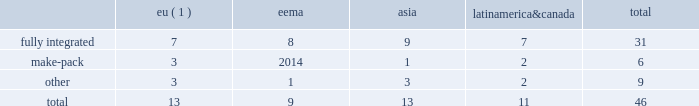2022 the failure of our information systems to function as intended or their penetration by outside parties with the intent to corrupt them or our failure to comply with privacy laws and regulations could result in business disruption , litigation and regulatory action , and loss of revenue , assets or personal or other confidential data .
We use information systems to help manage business processes , collect and interpret business data and communicate internally and externally with employees , suppliers , customers and others .
Some of these information systems are managed by third-party service providers .
We have backup systems and business continuity plans in place , and we take care to protect our systems and data from unauthorized access .
Nevertheless , failure of our systems to function as intended , or penetration of our systems by outside parties intent on extracting or corrupting information or otherwise disrupting business processes , could place us at a competitive disadvantage , result in a loss of revenue , assets or personal or other sensitive data , litigation and regulatory action , cause damage to our reputation and that of our brands and result in significant remediation and other costs .
Failure to protect personal data and respect the rights of data subjects could subject us to substantial fines under regulations such as the eu general data protection regulation .
2022 we may be required to replace third-party contract manufacturers or service providers with our own resources .
In certain instances , we contract with third parties to manufacture some of our products or product parts or to provide other services .
We may be unable to renew these agreements on satisfactory terms for numerous reasons , including government regulations .
Accordingly , our costs may increase significantly if we must replace such third parties with our own resources .
Item 1b .
Unresolved staff comments .
Item 2 .
Properties .
At december 31 , 2017 , we operated and owned 46 manufacturing facilities and maintained contract manufacturing relationships with 25 third-party manufacturers across 23 markets .
In addition , we work with 38 third-party operators in indonesia who manufacture our hand-rolled cigarettes .
Pmi-owned manufacturing facilities eema asia america canada total .
( 1 ) includes facilities that produced heated tobacco units in 2017 .
In 2017 , 23 of our facilities each manufactured over 10 billion cigarettes , of which eight facilities each produced over 30 billion units .
Our largest factories are in karawang and sukorejo ( indonesia ) , izmir ( turkey ) , krakow ( poland ) , st .
Petersburg and krasnodar ( russia ) , batangas and marikina ( philippines ) , berlin ( germany ) , kharkiv ( ukraine ) , and kutna hora ( czech republic ) .
Our smallest factories are mostly in latin america and asia , where due to tariff and other constraints we have established small manufacturing units in individual markets .
We will continue to optimize our manufacturing base , taking into consideration the evolution of trade blocks .
The plants and properties owned or leased and operated by our subsidiaries are maintained in good condition and are believed to be suitable and adequate for our present needs .
We are integrating the production of heated tobacco units into a number of our existing manufacturing facilities and progressing with our plans to build manufacturing capacity for our other rrp platforms. .
What percentage of pmi-owned manufacturing facilities eema asia america canada are in asia? 
Computations: (13 / 46)
Answer: 0.28261. 2022 the failure of our information systems to function as intended or their penetration by outside parties with the intent to corrupt them or our failure to comply with privacy laws and regulations could result in business disruption , litigation and regulatory action , and loss of revenue , assets or personal or other confidential data .
We use information systems to help manage business processes , collect and interpret business data and communicate internally and externally with employees , suppliers , customers and others .
Some of these information systems are managed by third-party service providers .
We have backup systems and business continuity plans in place , and we take care to protect our systems and data from unauthorized access .
Nevertheless , failure of our systems to function as intended , or penetration of our systems by outside parties intent on extracting or corrupting information or otherwise disrupting business processes , could place us at a competitive disadvantage , result in a loss of revenue , assets or personal or other sensitive data , litigation and regulatory action , cause damage to our reputation and that of our brands and result in significant remediation and other costs .
Failure to protect personal data and respect the rights of data subjects could subject us to substantial fines under regulations such as the eu general data protection regulation .
2022 we may be required to replace third-party contract manufacturers or service providers with our own resources .
In certain instances , we contract with third parties to manufacture some of our products or product parts or to provide other services .
We may be unable to renew these agreements on satisfactory terms for numerous reasons , including government regulations .
Accordingly , our costs may increase significantly if we must replace such third parties with our own resources .
Item 1b .
Unresolved staff comments .
Item 2 .
Properties .
At december 31 , 2017 , we operated and owned 46 manufacturing facilities and maintained contract manufacturing relationships with 25 third-party manufacturers across 23 markets .
In addition , we work with 38 third-party operators in indonesia who manufacture our hand-rolled cigarettes .
Pmi-owned manufacturing facilities eema asia america canada total .
( 1 ) includes facilities that produced heated tobacco units in 2017 .
In 2017 , 23 of our facilities each manufactured over 10 billion cigarettes , of which eight facilities each produced over 30 billion units .
Our largest factories are in karawang and sukorejo ( indonesia ) , izmir ( turkey ) , krakow ( poland ) , st .
Petersburg and krasnodar ( russia ) , batangas and marikina ( philippines ) , berlin ( germany ) , kharkiv ( ukraine ) , and kutna hora ( czech republic ) .
Our smallest factories are mostly in latin america and asia , where due to tariff and other constraints we have established small manufacturing units in individual markets .
We will continue to optimize our manufacturing base , taking into consideration the evolution of trade blocks .
The plants and properties owned or leased and operated by our subsidiaries are maintained in good condition and are believed to be suitable and adequate for our present needs .
We are integrating the production of heated tobacco units into a number of our existing manufacturing facilities and progressing with our plans to build manufacturing capacity for our other rrp platforms. .
What percentage of pmi-owned manufacturing facilities eema asia america canada are in eu? 
Computations: (13 / 46)
Answer: 0.28261. 